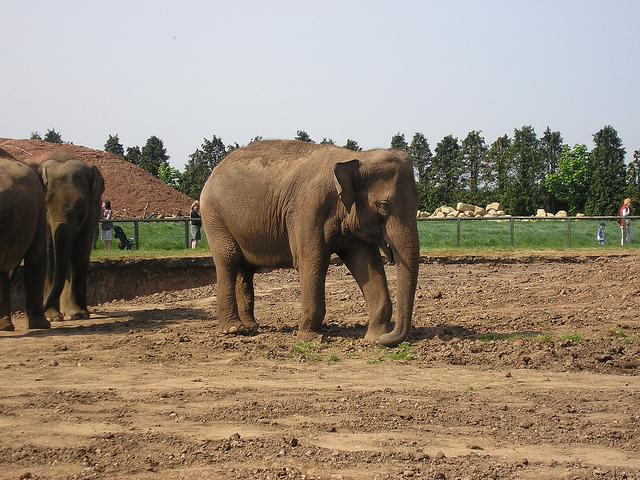Is the elephant dirty?
Short answer required. Yes. Could this be in the wild?
Keep it brief. No. Are the elephants fenced in?
Short answer required. Yes. Is the elephant in the wild or captivity?
Answer briefly. Captivity. 